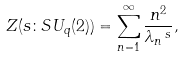Convert formula to latex. <formula><loc_0><loc_0><loc_500><loc_500>Z ( s \colon S U _ { q } ( 2 ) ) = \sum _ { n = 1 } ^ { \infty } \frac { n ^ { 2 } } { \lambda _ { n } \, ^ { s } } ,</formula> 